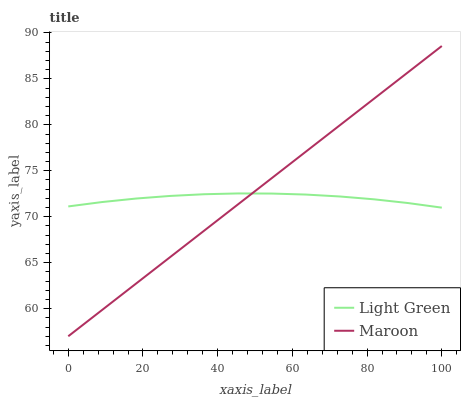Does Light Green have the minimum area under the curve?
Answer yes or no. Yes. Does Maroon have the maximum area under the curve?
Answer yes or no. Yes. Does Light Green have the maximum area under the curve?
Answer yes or no. No. Is Maroon the smoothest?
Answer yes or no. Yes. Is Light Green the roughest?
Answer yes or no. Yes. Is Light Green the smoothest?
Answer yes or no. No. Does Light Green have the lowest value?
Answer yes or no. No. Does Light Green have the highest value?
Answer yes or no. No. 